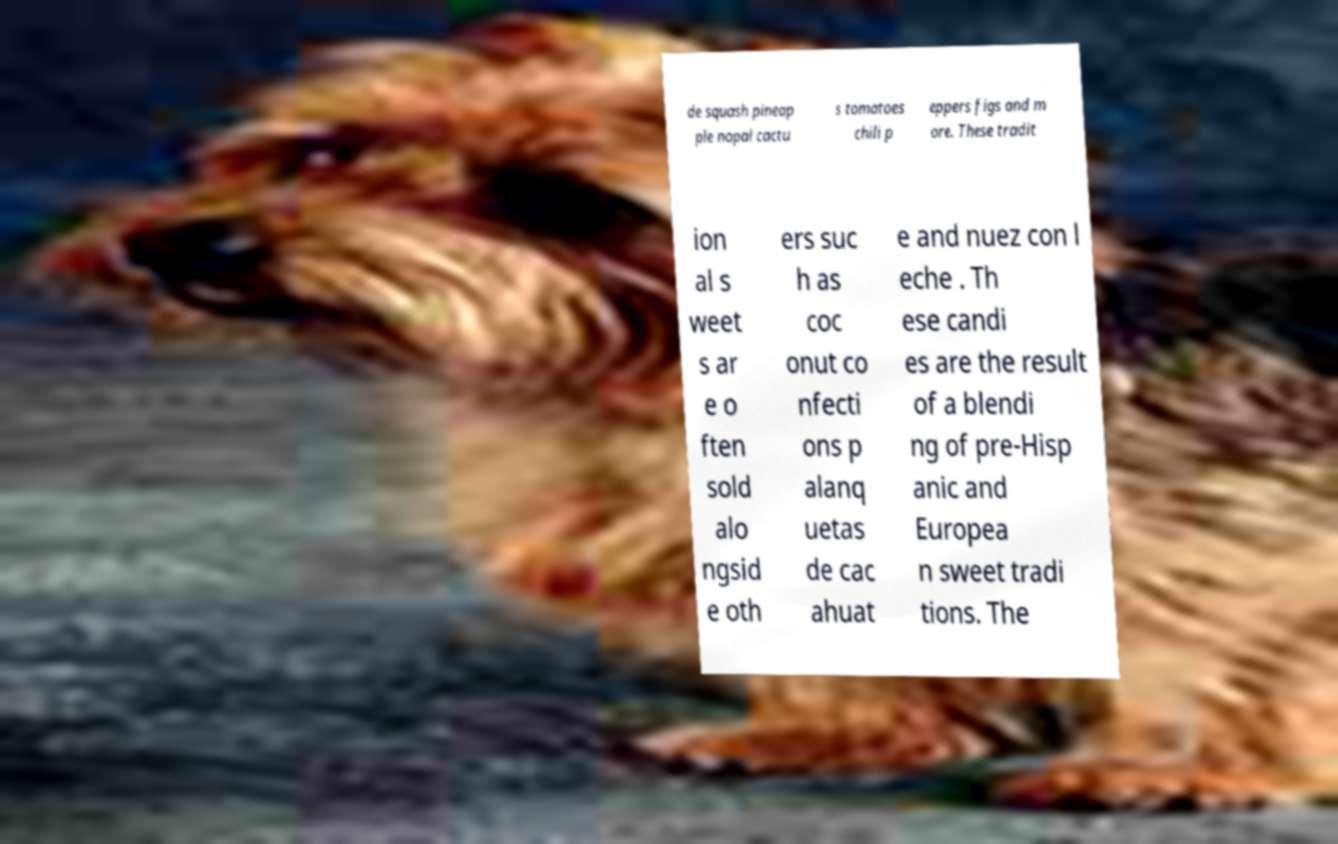For documentation purposes, I need the text within this image transcribed. Could you provide that? de squash pineap ple nopal cactu s tomatoes chili p eppers figs and m ore. These tradit ion al s weet s ar e o ften sold alo ngsid e oth ers suc h as coc onut co nfecti ons p alanq uetas de cac ahuat e and nuez con l eche . Th ese candi es are the result of a blendi ng of pre-Hisp anic and Europea n sweet tradi tions. The 